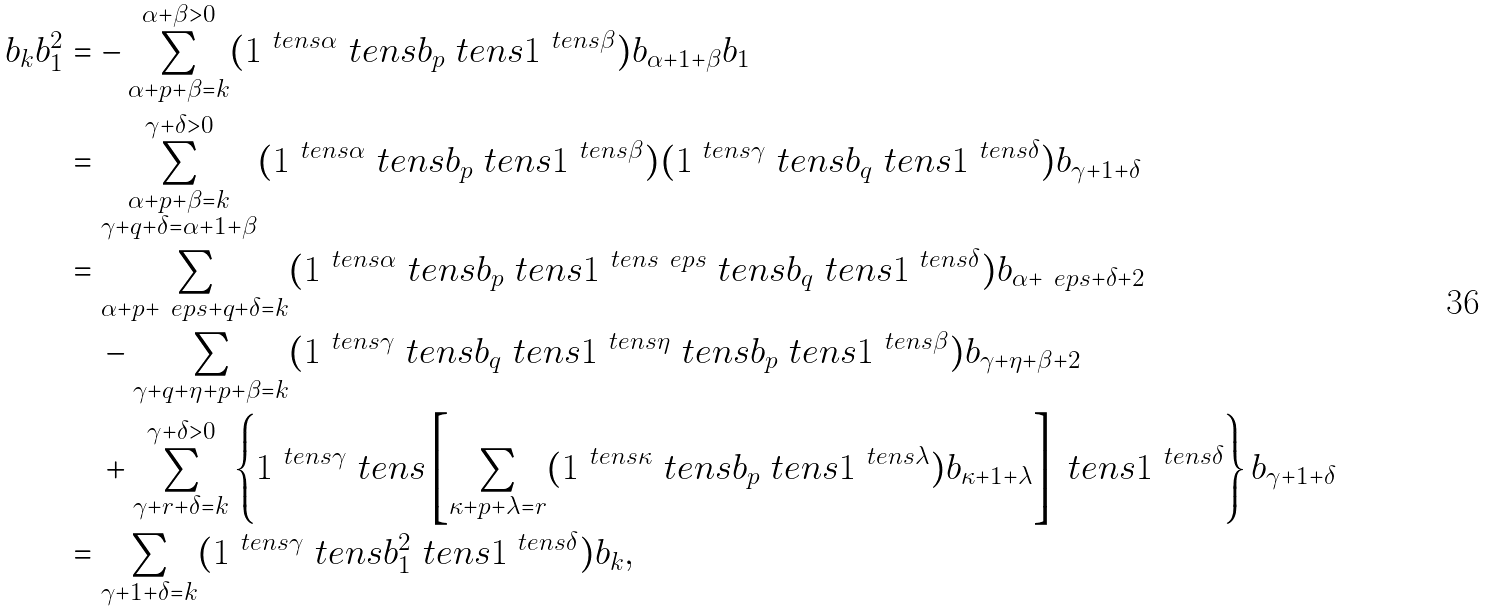Convert formula to latex. <formula><loc_0><loc_0><loc_500><loc_500>b _ { k } b _ { 1 } ^ { 2 } & = - \sum _ { \alpha + p + \beta = k } ^ { \alpha + \beta > 0 } ( 1 ^ { \ t e n s \alpha } \ t e n s b _ { p } \ t e n s 1 ^ { \ t e n s \beta } ) b _ { \alpha + 1 + \beta } b _ { 1 } \\ & = \sum _ { \substack { \alpha + p + \beta = k \\ \gamma + q + \delta = \alpha + 1 + \beta } } ^ { \gamma + \delta > 0 } ( 1 ^ { \ t e n s \alpha } \ t e n s b _ { p } \ t e n s 1 ^ { \ t e n s \beta } ) ( 1 ^ { \ t e n s \gamma } \ t e n s b _ { q } \ t e n s 1 ^ { \ t e n s \delta } ) b _ { \gamma + 1 + \delta } \\ & = \sum _ { \alpha + p + \ e p s + q + \delta = k } ( 1 ^ { \ t e n s \alpha } \ t e n s b _ { p } \ t e n s 1 ^ { \ t e n s \ e p s } \ t e n s b _ { q } \ t e n s 1 ^ { \ t e n s \delta } ) b _ { \alpha + \ e p s + \delta + 2 } \\ & \quad - \sum _ { \gamma + q + \eta + p + \beta = k } ( 1 ^ { \ t e n s \gamma } \ t e n s b _ { q } \ t e n s 1 ^ { \ t e n s \eta } \ t e n s b _ { p } \ t e n s 1 ^ { \ t e n s \beta } ) b _ { \gamma + \eta + \beta + 2 } \\ & \quad + \sum _ { \gamma + r + \delta = k } ^ { \gamma + \delta > 0 } \left \{ 1 ^ { \ t e n s \gamma } \ t e n s \left [ \sum _ { \kappa + p + \lambda = r } ( 1 ^ { \ t e n s \kappa } \ t e n s b _ { p } \ t e n s 1 ^ { \ t e n s \lambda } ) b _ { \kappa + 1 + \lambda } \right ] \ t e n s 1 ^ { \ t e n s \delta } \right \} b _ { \gamma + 1 + \delta } \\ & = \sum _ { \gamma + 1 + \delta = k } ( 1 ^ { \ t e n s \gamma } \ t e n s b _ { 1 } ^ { 2 } \ t e n s 1 ^ { \ t e n s \delta } ) b _ { k } ,</formula> 